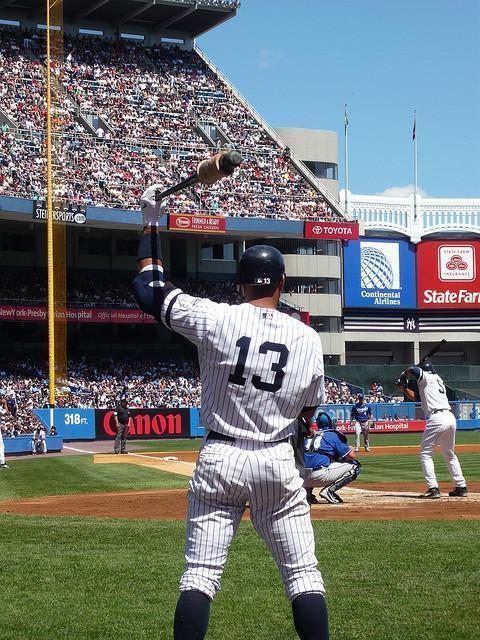What is the thing on the baseball bat for?
From the following set of four choices, select the accurate answer to respond to the question.
Options: Warming up, cheating, just aesthetics, making noise. Warming up. 